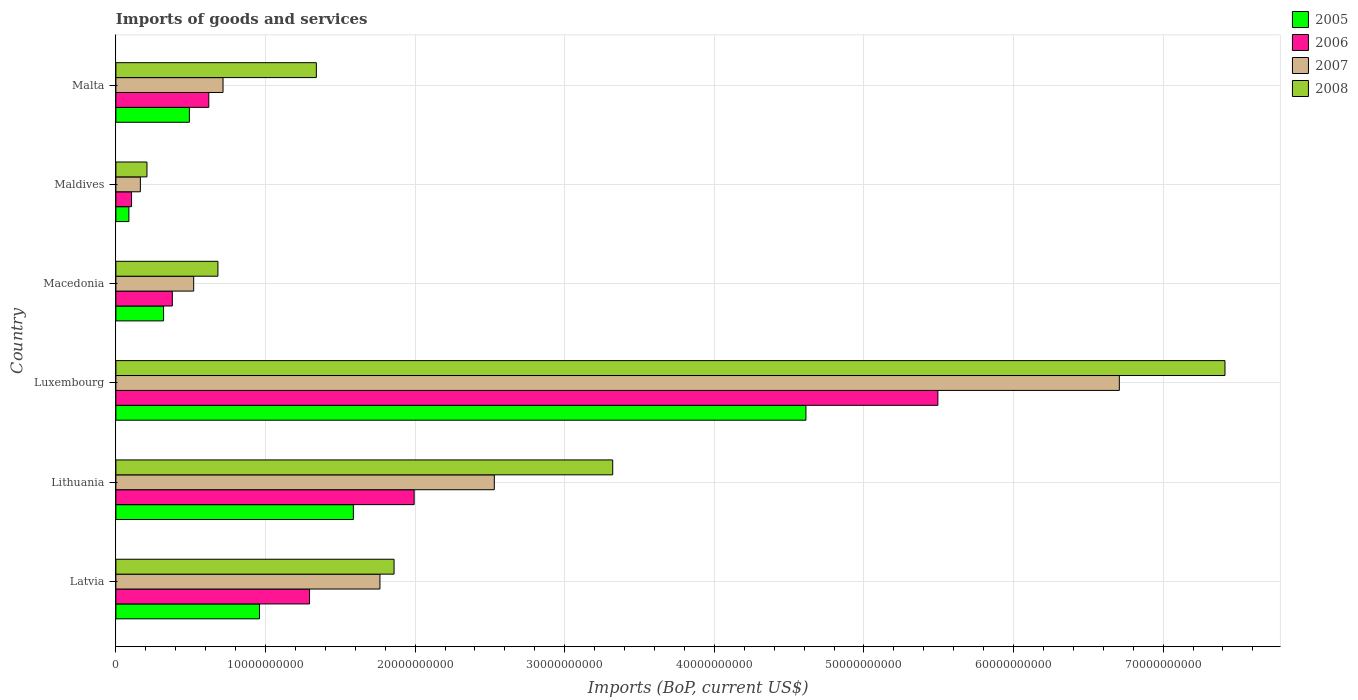How many different coloured bars are there?
Provide a succinct answer. 4. How many groups of bars are there?
Make the answer very short. 6. Are the number of bars per tick equal to the number of legend labels?
Give a very brief answer. Yes. How many bars are there on the 6th tick from the bottom?
Give a very brief answer. 4. What is the label of the 6th group of bars from the top?
Your response must be concise. Latvia. In how many cases, is the number of bars for a given country not equal to the number of legend labels?
Your answer should be very brief. 0. What is the amount spent on imports in 2008 in Lithuania?
Provide a succinct answer. 3.32e+1. Across all countries, what is the maximum amount spent on imports in 2005?
Offer a terse response. 4.61e+1. Across all countries, what is the minimum amount spent on imports in 2007?
Make the answer very short. 1.64e+09. In which country was the amount spent on imports in 2008 maximum?
Provide a succinct answer. Luxembourg. In which country was the amount spent on imports in 2007 minimum?
Offer a very short reply. Maldives. What is the total amount spent on imports in 2007 in the graph?
Provide a short and direct response. 1.24e+11. What is the difference between the amount spent on imports in 2007 in Macedonia and that in Maldives?
Give a very brief answer. 3.56e+09. What is the difference between the amount spent on imports in 2005 in Malta and the amount spent on imports in 2008 in Lithuania?
Provide a short and direct response. -2.83e+1. What is the average amount spent on imports in 2005 per country?
Your response must be concise. 1.34e+1. What is the difference between the amount spent on imports in 2005 and amount spent on imports in 2006 in Macedonia?
Your response must be concise. -5.85e+08. In how many countries, is the amount spent on imports in 2008 greater than 70000000000 US$?
Your response must be concise. 1. What is the ratio of the amount spent on imports in 2006 in Latvia to that in Lithuania?
Provide a short and direct response. 0.65. What is the difference between the highest and the second highest amount spent on imports in 2007?
Provide a succinct answer. 4.18e+1. What is the difference between the highest and the lowest amount spent on imports in 2007?
Offer a terse response. 6.54e+1. In how many countries, is the amount spent on imports in 2008 greater than the average amount spent on imports in 2008 taken over all countries?
Provide a succinct answer. 2. Is the sum of the amount spent on imports in 2005 in Luxembourg and Macedonia greater than the maximum amount spent on imports in 2007 across all countries?
Keep it short and to the point. No. Is it the case that in every country, the sum of the amount spent on imports in 2007 and amount spent on imports in 2008 is greater than the amount spent on imports in 2005?
Your answer should be compact. Yes. Are all the bars in the graph horizontal?
Your answer should be compact. Yes. What is the difference between two consecutive major ticks on the X-axis?
Offer a very short reply. 1.00e+1. Does the graph contain grids?
Offer a terse response. Yes. Where does the legend appear in the graph?
Provide a succinct answer. Top right. How many legend labels are there?
Provide a succinct answer. 4. What is the title of the graph?
Make the answer very short. Imports of goods and services. What is the label or title of the X-axis?
Your answer should be compact. Imports (BoP, current US$). What is the Imports (BoP, current US$) in 2005 in Latvia?
Offer a very short reply. 9.60e+09. What is the Imports (BoP, current US$) of 2006 in Latvia?
Provide a succinct answer. 1.29e+1. What is the Imports (BoP, current US$) in 2007 in Latvia?
Make the answer very short. 1.76e+1. What is the Imports (BoP, current US$) in 2008 in Latvia?
Give a very brief answer. 1.86e+1. What is the Imports (BoP, current US$) of 2005 in Lithuania?
Provide a succinct answer. 1.59e+1. What is the Imports (BoP, current US$) in 2006 in Lithuania?
Your response must be concise. 1.99e+1. What is the Imports (BoP, current US$) in 2007 in Lithuania?
Give a very brief answer. 2.53e+1. What is the Imports (BoP, current US$) in 2008 in Lithuania?
Offer a terse response. 3.32e+1. What is the Imports (BoP, current US$) in 2005 in Luxembourg?
Your response must be concise. 4.61e+1. What is the Imports (BoP, current US$) of 2006 in Luxembourg?
Provide a short and direct response. 5.49e+1. What is the Imports (BoP, current US$) of 2007 in Luxembourg?
Provide a short and direct response. 6.71e+1. What is the Imports (BoP, current US$) in 2008 in Luxembourg?
Offer a terse response. 7.41e+1. What is the Imports (BoP, current US$) in 2005 in Macedonia?
Your answer should be very brief. 3.19e+09. What is the Imports (BoP, current US$) in 2006 in Macedonia?
Make the answer very short. 3.77e+09. What is the Imports (BoP, current US$) in 2007 in Macedonia?
Provide a succinct answer. 5.20e+09. What is the Imports (BoP, current US$) in 2008 in Macedonia?
Your answer should be compact. 6.82e+09. What is the Imports (BoP, current US$) in 2005 in Maldives?
Provide a short and direct response. 8.69e+08. What is the Imports (BoP, current US$) of 2006 in Maldives?
Provide a short and direct response. 1.05e+09. What is the Imports (BoP, current US$) of 2007 in Maldives?
Your response must be concise. 1.64e+09. What is the Imports (BoP, current US$) in 2008 in Maldives?
Your response must be concise. 2.08e+09. What is the Imports (BoP, current US$) in 2005 in Malta?
Provide a short and direct response. 4.91e+09. What is the Imports (BoP, current US$) in 2006 in Malta?
Offer a very short reply. 6.21e+09. What is the Imports (BoP, current US$) in 2007 in Malta?
Make the answer very short. 7.16e+09. What is the Imports (BoP, current US$) of 2008 in Malta?
Keep it short and to the point. 1.34e+1. Across all countries, what is the maximum Imports (BoP, current US$) of 2005?
Keep it short and to the point. 4.61e+1. Across all countries, what is the maximum Imports (BoP, current US$) in 2006?
Give a very brief answer. 5.49e+1. Across all countries, what is the maximum Imports (BoP, current US$) in 2007?
Offer a very short reply. 6.71e+1. Across all countries, what is the maximum Imports (BoP, current US$) in 2008?
Make the answer very short. 7.41e+1. Across all countries, what is the minimum Imports (BoP, current US$) in 2005?
Offer a terse response. 8.69e+08. Across all countries, what is the minimum Imports (BoP, current US$) of 2006?
Offer a terse response. 1.05e+09. Across all countries, what is the minimum Imports (BoP, current US$) of 2007?
Offer a terse response. 1.64e+09. Across all countries, what is the minimum Imports (BoP, current US$) of 2008?
Provide a short and direct response. 2.08e+09. What is the total Imports (BoP, current US$) of 2005 in the graph?
Your answer should be compact. 8.06e+1. What is the total Imports (BoP, current US$) of 2006 in the graph?
Offer a terse response. 9.89e+1. What is the total Imports (BoP, current US$) of 2007 in the graph?
Give a very brief answer. 1.24e+11. What is the total Imports (BoP, current US$) in 2008 in the graph?
Make the answer very short. 1.48e+11. What is the difference between the Imports (BoP, current US$) of 2005 in Latvia and that in Lithuania?
Give a very brief answer. -6.28e+09. What is the difference between the Imports (BoP, current US$) in 2006 in Latvia and that in Lithuania?
Keep it short and to the point. -6.99e+09. What is the difference between the Imports (BoP, current US$) of 2007 in Latvia and that in Lithuania?
Offer a terse response. -7.65e+09. What is the difference between the Imports (BoP, current US$) in 2008 in Latvia and that in Lithuania?
Keep it short and to the point. -1.46e+1. What is the difference between the Imports (BoP, current US$) in 2005 in Latvia and that in Luxembourg?
Offer a very short reply. -3.65e+1. What is the difference between the Imports (BoP, current US$) in 2006 in Latvia and that in Luxembourg?
Provide a succinct answer. -4.20e+1. What is the difference between the Imports (BoP, current US$) of 2007 in Latvia and that in Luxembourg?
Give a very brief answer. -4.94e+1. What is the difference between the Imports (BoP, current US$) of 2008 in Latvia and that in Luxembourg?
Offer a very short reply. -5.55e+1. What is the difference between the Imports (BoP, current US$) in 2005 in Latvia and that in Macedonia?
Your response must be concise. 6.41e+09. What is the difference between the Imports (BoP, current US$) in 2006 in Latvia and that in Macedonia?
Your answer should be compact. 9.17e+09. What is the difference between the Imports (BoP, current US$) of 2007 in Latvia and that in Macedonia?
Ensure brevity in your answer.  1.24e+1. What is the difference between the Imports (BoP, current US$) in 2008 in Latvia and that in Macedonia?
Give a very brief answer. 1.18e+1. What is the difference between the Imports (BoP, current US$) of 2005 in Latvia and that in Maldives?
Your response must be concise. 8.73e+09. What is the difference between the Imports (BoP, current US$) in 2006 in Latvia and that in Maldives?
Keep it short and to the point. 1.19e+1. What is the difference between the Imports (BoP, current US$) in 2007 in Latvia and that in Maldives?
Your answer should be compact. 1.60e+1. What is the difference between the Imports (BoP, current US$) of 2008 in Latvia and that in Maldives?
Your response must be concise. 1.65e+1. What is the difference between the Imports (BoP, current US$) of 2005 in Latvia and that in Malta?
Keep it short and to the point. 4.69e+09. What is the difference between the Imports (BoP, current US$) of 2006 in Latvia and that in Malta?
Your answer should be compact. 6.73e+09. What is the difference between the Imports (BoP, current US$) of 2007 in Latvia and that in Malta?
Keep it short and to the point. 1.05e+1. What is the difference between the Imports (BoP, current US$) of 2008 in Latvia and that in Malta?
Offer a terse response. 5.20e+09. What is the difference between the Imports (BoP, current US$) of 2005 in Lithuania and that in Luxembourg?
Give a very brief answer. -3.03e+1. What is the difference between the Imports (BoP, current US$) in 2006 in Lithuania and that in Luxembourg?
Provide a succinct answer. -3.50e+1. What is the difference between the Imports (BoP, current US$) in 2007 in Lithuania and that in Luxembourg?
Your answer should be very brief. -4.18e+1. What is the difference between the Imports (BoP, current US$) of 2008 in Lithuania and that in Luxembourg?
Offer a terse response. -4.09e+1. What is the difference between the Imports (BoP, current US$) in 2005 in Lithuania and that in Macedonia?
Your answer should be very brief. 1.27e+1. What is the difference between the Imports (BoP, current US$) of 2006 in Lithuania and that in Macedonia?
Offer a terse response. 1.62e+1. What is the difference between the Imports (BoP, current US$) in 2007 in Lithuania and that in Macedonia?
Provide a short and direct response. 2.01e+1. What is the difference between the Imports (BoP, current US$) of 2008 in Lithuania and that in Macedonia?
Provide a succinct answer. 2.64e+1. What is the difference between the Imports (BoP, current US$) in 2005 in Lithuania and that in Maldives?
Ensure brevity in your answer.  1.50e+1. What is the difference between the Imports (BoP, current US$) in 2006 in Lithuania and that in Maldives?
Keep it short and to the point. 1.89e+1. What is the difference between the Imports (BoP, current US$) in 2007 in Lithuania and that in Maldives?
Make the answer very short. 2.37e+1. What is the difference between the Imports (BoP, current US$) in 2008 in Lithuania and that in Maldives?
Your answer should be compact. 3.11e+1. What is the difference between the Imports (BoP, current US$) in 2005 in Lithuania and that in Malta?
Give a very brief answer. 1.10e+1. What is the difference between the Imports (BoP, current US$) in 2006 in Lithuania and that in Malta?
Give a very brief answer. 1.37e+1. What is the difference between the Imports (BoP, current US$) in 2007 in Lithuania and that in Malta?
Your answer should be compact. 1.81e+1. What is the difference between the Imports (BoP, current US$) of 2008 in Lithuania and that in Malta?
Offer a terse response. 1.98e+1. What is the difference between the Imports (BoP, current US$) of 2005 in Luxembourg and that in Macedonia?
Your response must be concise. 4.29e+1. What is the difference between the Imports (BoP, current US$) in 2006 in Luxembourg and that in Macedonia?
Keep it short and to the point. 5.12e+1. What is the difference between the Imports (BoP, current US$) in 2007 in Luxembourg and that in Macedonia?
Your response must be concise. 6.19e+1. What is the difference between the Imports (BoP, current US$) of 2008 in Luxembourg and that in Macedonia?
Give a very brief answer. 6.73e+1. What is the difference between the Imports (BoP, current US$) in 2005 in Luxembourg and that in Maldives?
Ensure brevity in your answer.  4.53e+1. What is the difference between the Imports (BoP, current US$) in 2006 in Luxembourg and that in Maldives?
Provide a succinct answer. 5.39e+1. What is the difference between the Imports (BoP, current US$) in 2007 in Luxembourg and that in Maldives?
Give a very brief answer. 6.54e+1. What is the difference between the Imports (BoP, current US$) of 2008 in Luxembourg and that in Maldives?
Offer a very short reply. 7.21e+1. What is the difference between the Imports (BoP, current US$) in 2005 in Luxembourg and that in Malta?
Give a very brief answer. 4.12e+1. What is the difference between the Imports (BoP, current US$) of 2006 in Luxembourg and that in Malta?
Provide a short and direct response. 4.87e+1. What is the difference between the Imports (BoP, current US$) of 2007 in Luxembourg and that in Malta?
Ensure brevity in your answer.  5.99e+1. What is the difference between the Imports (BoP, current US$) of 2008 in Luxembourg and that in Malta?
Your response must be concise. 6.07e+1. What is the difference between the Imports (BoP, current US$) of 2005 in Macedonia and that in Maldives?
Offer a very short reply. 2.32e+09. What is the difference between the Imports (BoP, current US$) of 2006 in Macedonia and that in Maldives?
Your response must be concise. 2.73e+09. What is the difference between the Imports (BoP, current US$) of 2007 in Macedonia and that in Maldives?
Offer a very short reply. 3.56e+09. What is the difference between the Imports (BoP, current US$) in 2008 in Macedonia and that in Maldives?
Your answer should be compact. 4.74e+09. What is the difference between the Imports (BoP, current US$) of 2005 in Macedonia and that in Malta?
Give a very brief answer. -1.72e+09. What is the difference between the Imports (BoP, current US$) of 2006 in Macedonia and that in Malta?
Provide a succinct answer. -2.44e+09. What is the difference between the Imports (BoP, current US$) of 2007 in Macedonia and that in Malta?
Provide a short and direct response. -1.96e+09. What is the difference between the Imports (BoP, current US$) of 2008 in Macedonia and that in Malta?
Ensure brevity in your answer.  -6.58e+09. What is the difference between the Imports (BoP, current US$) of 2005 in Maldives and that in Malta?
Your answer should be very brief. -4.04e+09. What is the difference between the Imports (BoP, current US$) in 2006 in Maldives and that in Malta?
Keep it short and to the point. -5.16e+09. What is the difference between the Imports (BoP, current US$) in 2007 in Maldives and that in Malta?
Provide a short and direct response. -5.53e+09. What is the difference between the Imports (BoP, current US$) in 2008 in Maldives and that in Malta?
Offer a very short reply. -1.13e+1. What is the difference between the Imports (BoP, current US$) of 2005 in Latvia and the Imports (BoP, current US$) of 2006 in Lithuania?
Offer a terse response. -1.03e+1. What is the difference between the Imports (BoP, current US$) of 2005 in Latvia and the Imports (BoP, current US$) of 2007 in Lithuania?
Give a very brief answer. -1.57e+1. What is the difference between the Imports (BoP, current US$) in 2005 in Latvia and the Imports (BoP, current US$) in 2008 in Lithuania?
Keep it short and to the point. -2.36e+1. What is the difference between the Imports (BoP, current US$) in 2006 in Latvia and the Imports (BoP, current US$) in 2007 in Lithuania?
Your answer should be very brief. -1.24e+1. What is the difference between the Imports (BoP, current US$) in 2006 in Latvia and the Imports (BoP, current US$) in 2008 in Lithuania?
Your answer should be very brief. -2.03e+1. What is the difference between the Imports (BoP, current US$) in 2007 in Latvia and the Imports (BoP, current US$) in 2008 in Lithuania?
Offer a terse response. -1.56e+1. What is the difference between the Imports (BoP, current US$) of 2005 in Latvia and the Imports (BoP, current US$) of 2006 in Luxembourg?
Your answer should be compact. -4.53e+1. What is the difference between the Imports (BoP, current US$) of 2005 in Latvia and the Imports (BoP, current US$) of 2007 in Luxembourg?
Provide a succinct answer. -5.75e+1. What is the difference between the Imports (BoP, current US$) of 2005 in Latvia and the Imports (BoP, current US$) of 2008 in Luxembourg?
Provide a short and direct response. -6.45e+1. What is the difference between the Imports (BoP, current US$) of 2006 in Latvia and the Imports (BoP, current US$) of 2007 in Luxembourg?
Offer a terse response. -5.41e+1. What is the difference between the Imports (BoP, current US$) in 2006 in Latvia and the Imports (BoP, current US$) in 2008 in Luxembourg?
Your answer should be very brief. -6.12e+1. What is the difference between the Imports (BoP, current US$) of 2007 in Latvia and the Imports (BoP, current US$) of 2008 in Luxembourg?
Keep it short and to the point. -5.65e+1. What is the difference between the Imports (BoP, current US$) of 2005 in Latvia and the Imports (BoP, current US$) of 2006 in Macedonia?
Provide a short and direct response. 5.83e+09. What is the difference between the Imports (BoP, current US$) of 2005 in Latvia and the Imports (BoP, current US$) of 2007 in Macedonia?
Keep it short and to the point. 4.40e+09. What is the difference between the Imports (BoP, current US$) of 2005 in Latvia and the Imports (BoP, current US$) of 2008 in Macedonia?
Ensure brevity in your answer.  2.78e+09. What is the difference between the Imports (BoP, current US$) in 2006 in Latvia and the Imports (BoP, current US$) in 2007 in Macedonia?
Provide a succinct answer. 7.74e+09. What is the difference between the Imports (BoP, current US$) of 2006 in Latvia and the Imports (BoP, current US$) of 2008 in Macedonia?
Your answer should be compact. 6.12e+09. What is the difference between the Imports (BoP, current US$) in 2007 in Latvia and the Imports (BoP, current US$) in 2008 in Macedonia?
Give a very brief answer. 1.08e+1. What is the difference between the Imports (BoP, current US$) in 2005 in Latvia and the Imports (BoP, current US$) in 2006 in Maldives?
Your answer should be compact. 8.55e+09. What is the difference between the Imports (BoP, current US$) of 2005 in Latvia and the Imports (BoP, current US$) of 2007 in Maldives?
Provide a short and direct response. 7.96e+09. What is the difference between the Imports (BoP, current US$) in 2005 in Latvia and the Imports (BoP, current US$) in 2008 in Maldives?
Your response must be concise. 7.52e+09. What is the difference between the Imports (BoP, current US$) in 2006 in Latvia and the Imports (BoP, current US$) in 2007 in Maldives?
Offer a very short reply. 1.13e+1. What is the difference between the Imports (BoP, current US$) of 2006 in Latvia and the Imports (BoP, current US$) of 2008 in Maldives?
Ensure brevity in your answer.  1.09e+1. What is the difference between the Imports (BoP, current US$) in 2007 in Latvia and the Imports (BoP, current US$) in 2008 in Maldives?
Ensure brevity in your answer.  1.56e+1. What is the difference between the Imports (BoP, current US$) of 2005 in Latvia and the Imports (BoP, current US$) of 2006 in Malta?
Your response must be concise. 3.39e+09. What is the difference between the Imports (BoP, current US$) of 2005 in Latvia and the Imports (BoP, current US$) of 2007 in Malta?
Offer a very short reply. 2.44e+09. What is the difference between the Imports (BoP, current US$) of 2005 in Latvia and the Imports (BoP, current US$) of 2008 in Malta?
Offer a very short reply. -3.80e+09. What is the difference between the Imports (BoP, current US$) of 2006 in Latvia and the Imports (BoP, current US$) of 2007 in Malta?
Your answer should be very brief. 5.78e+09. What is the difference between the Imports (BoP, current US$) of 2006 in Latvia and the Imports (BoP, current US$) of 2008 in Malta?
Provide a succinct answer. -4.55e+08. What is the difference between the Imports (BoP, current US$) of 2007 in Latvia and the Imports (BoP, current US$) of 2008 in Malta?
Offer a very short reply. 4.25e+09. What is the difference between the Imports (BoP, current US$) of 2005 in Lithuania and the Imports (BoP, current US$) of 2006 in Luxembourg?
Your response must be concise. -3.91e+1. What is the difference between the Imports (BoP, current US$) in 2005 in Lithuania and the Imports (BoP, current US$) in 2007 in Luxembourg?
Provide a short and direct response. -5.12e+1. What is the difference between the Imports (BoP, current US$) of 2005 in Lithuania and the Imports (BoP, current US$) of 2008 in Luxembourg?
Offer a terse response. -5.83e+1. What is the difference between the Imports (BoP, current US$) in 2006 in Lithuania and the Imports (BoP, current US$) in 2007 in Luxembourg?
Provide a succinct answer. -4.71e+1. What is the difference between the Imports (BoP, current US$) in 2006 in Lithuania and the Imports (BoP, current US$) in 2008 in Luxembourg?
Give a very brief answer. -5.42e+1. What is the difference between the Imports (BoP, current US$) of 2007 in Lithuania and the Imports (BoP, current US$) of 2008 in Luxembourg?
Keep it short and to the point. -4.88e+1. What is the difference between the Imports (BoP, current US$) of 2005 in Lithuania and the Imports (BoP, current US$) of 2006 in Macedonia?
Your answer should be compact. 1.21e+1. What is the difference between the Imports (BoP, current US$) in 2005 in Lithuania and the Imports (BoP, current US$) in 2007 in Macedonia?
Make the answer very short. 1.07e+1. What is the difference between the Imports (BoP, current US$) in 2005 in Lithuania and the Imports (BoP, current US$) in 2008 in Macedonia?
Give a very brief answer. 9.05e+09. What is the difference between the Imports (BoP, current US$) of 2006 in Lithuania and the Imports (BoP, current US$) of 2007 in Macedonia?
Offer a very short reply. 1.47e+1. What is the difference between the Imports (BoP, current US$) in 2006 in Lithuania and the Imports (BoP, current US$) in 2008 in Macedonia?
Ensure brevity in your answer.  1.31e+1. What is the difference between the Imports (BoP, current US$) of 2007 in Lithuania and the Imports (BoP, current US$) of 2008 in Macedonia?
Provide a short and direct response. 1.85e+1. What is the difference between the Imports (BoP, current US$) in 2005 in Lithuania and the Imports (BoP, current US$) in 2006 in Maldives?
Your answer should be compact. 1.48e+1. What is the difference between the Imports (BoP, current US$) of 2005 in Lithuania and the Imports (BoP, current US$) of 2007 in Maldives?
Ensure brevity in your answer.  1.42e+1. What is the difference between the Imports (BoP, current US$) in 2005 in Lithuania and the Imports (BoP, current US$) in 2008 in Maldives?
Make the answer very short. 1.38e+1. What is the difference between the Imports (BoP, current US$) in 2006 in Lithuania and the Imports (BoP, current US$) in 2007 in Maldives?
Make the answer very short. 1.83e+1. What is the difference between the Imports (BoP, current US$) of 2006 in Lithuania and the Imports (BoP, current US$) of 2008 in Maldives?
Ensure brevity in your answer.  1.79e+1. What is the difference between the Imports (BoP, current US$) of 2007 in Lithuania and the Imports (BoP, current US$) of 2008 in Maldives?
Give a very brief answer. 2.32e+1. What is the difference between the Imports (BoP, current US$) in 2005 in Lithuania and the Imports (BoP, current US$) in 2006 in Malta?
Ensure brevity in your answer.  9.66e+09. What is the difference between the Imports (BoP, current US$) in 2005 in Lithuania and the Imports (BoP, current US$) in 2007 in Malta?
Your response must be concise. 8.71e+09. What is the difference between the Imports (BoP, current US$) in 2005 in Lithuania and the Imports (BoP, current US$) in 2008 in Malta?
Give a very brief answer. 2.47e+09. What is the difference between the Imports (BoP, current US$) in 2006 in Lithuania and the Imports (BoP, current US$) in 2007 in Malta?
Your answer should be very brief. 1.28e+1. What is the difference between the Imports (BoP, current US$) of 2006 in Lithuania and the Imports (BoP, current US$) of 2008 in Malta?
Give a very brief answer. 6.54e+09. What is the difference between the Imports (BoP, current US$) in 2007 in Lithuania and the Imports (BoP, current US$) in 2008 in Malta?
Offer a very short reply. 1.19e+1. What is the difference between the Imports (BoP, current US$) in 2005 in Luxembourg and the Imports (BoP, current US$) in 2006 in Macedonia?
Offer a terse response. 4.24e+1. What is the difference between the Imports (BoP, current US$) in 2005 in Luxembourg and the Imports (BoP, current US$) in 2007 in Macedonia?
Keep it short and to the point. 4.09e+1. What is the difference between the Imports (BoP, current US$) in 2005 in Luxembourg and the Imports (BoP, current US$) in 2008 in Macedonia?
Your answer should be very brief. 3.93e+1. What is the difference between the Imports (BoP, current US$) of 2006 in Luxembourg and the Imports (BoP, current US$) of 2007 in Macedonia?
Provide a short and direct response. 4.97e+1. What is the difference between the Imports (BoP, current US$) in 2006 in Luxembourg and the Imports (BoP, current US$) in 2008 in Macedonia?
Offer a very short reply. 4.81e+1. What is the difference between the Imports (BoP, current US$) of 2007 in Luxembourg and the Imports (BoP, current US$) of 2008 in Macedonia?
Offer a terse response. 6.03e+1. What is the difference between the Imports (BoP, current US$) in 2005 in Luxembourg and the Imports (BoP, current US$) in 2006 in Maldives?
Your response must be concise. 4.51e+1. What is the difference between the Imports (BoP, current US$) in 2005 in Luxembourg and the Imports (BoP, current US$) in 2007 in Maldives?
Your answer should be compact. 4.45e+1. What is the difference between the Imports (BoP, current US$) in 2005 in Luxembourg and the Imports (BoP, current US$) in 2008 in Maldives?
Offer a very short reply. 4.40e+1. What is the difference between the Imports (BoP, current US$) in 2006 in Luxembourg and the Imports (BoP, current US$) in 2007 in Maldives?
Keep it short and to the point. 5.33e+1. What is the difference between the Imports (BoP, current US$) in 2006 in Luxembourg and the Imports (BoP, current US$) in 2008 in Maldives?
Keep it short and to the point. 5.29e+1. What is the difference between the Imports (BoP, current US$) of 2007 in Luxembourg and the Imports (BoP, current US$) of 2008 in Maldives?
Your response must be concise. 6.50e+1. What is the difference between the Imports (BoP, current US$) in 2005 in Luxembourg and the Imports (BoP, current US$) in 2006 in Malta?
Make the answer very short. 3.99e+1. What is the difference between the Imports (BoP, current US$) in 2005 in Luxembourg and the Imports (BoP, current US$) in 2007 in Malta?
Your answer should be very brief. 3.90e+1. What is the difference between the Imports (BoP, current US$) in 2005 in Luxembourg and the Imports (BoP, current US$) in 2008 in Malta?
Give a very brief answer. 3.27e+1. What is the difference between the Imports (BoP, current US$) in 2006 in Luxembourg and the Imports (BoP, current US$) in 2007 in Malta?
Provide a short and direct response. 4.78e+1. What is the difference between the Imports (BoP, current US$) in 2006 in Luxembourg and the Imports (BoP, current US$) in 2008 in Malta?
Provide a short and direct response. 4.15e+1. What is the difference between the Imports (BoP, current US$) of 2007 in Luxembourg and the Imports (BoP, current US$) of 2008 in Malta?
Provide a succinct answer. 5.37e+1. What is the difference between the Imports (BoP, current US$) of 2005 in Macedonia and the Imports (BoP, current US$) of 2006 in Maldives?
Give a very brief answer. 2.14e+09. What is the difference between the Imports (BoP, current US$) of 2005 in Macedonia and the Imports (BoP, current US$) of 2007 in Maldives?
Give a very brief answer. 1.55e+09. What is the difference between the Imports (BoP, current US$) of 2005 in Macedonia and the Imports (BoP, current US$) of 2008 in Maldives?
Offer a very short reply. 1.11e+09. What is the difference between the Imports (BoP, current US$) of 2006 in Macedonia and the Imports (BoP, current US$) of 2007 in Maldives?
Your answer should be very brief. 2.14e+09. What is the difference between the Imports (BoP, current US$) of 2006 in Macedonia and the Imports (BoP, current US$) of 2008 in Maldives?
Your answer should be compact. 1.70e+09. What is the difference between the Imports (BoP, current US$) of 2007 in Macedonia and the Imports (BoP, current US$) of 2008 in Maldives?
Your answer should be very brief. 3.12e+09. What is the difference between the Imports (BoP, current US$) in 2005 in Macedonia and the Imports (BoP, current US$) in 2006 in Malta?
Provide a short and direct response. -3.02e+09. What is the difference between the Imports (BoP, current US$) in 2005 in Macedonia and the Imports (BoP, current US$) in 2007 in Malta?
Your answer should be compact. -3.97e+09. What is the difference between the Imports (BoP, current US$) in 2005 in Macedonia and the Imports (BoP, current US$) in 2008 in Malta?
Make the answer very short. -1.02e+1. What is the difference between the Imports (BoP, current US$) in 2006 in Macedonia and the Imports (BoP, current US$) in 2007 in Malta?
Ensure brevity in your answer.  -3.39e+09. What is the difference between the Imports (BoP, current US$) in 2006 in Macedonia and the Imports (BoP, current US$) in 2008 in Malta?
Provide a succinct answer. -9.63e+09. What is the difference between the Imports (BoP, current US$) of 2007 in Macedonia and the Imports (BoP, current US$) of 2008 in Malta?
Ensure brevity in your answer.  -8.20e+09. What is the difference between the Imports (BoP, current US$) in 2005 in Maldives and the Imports (BoP, current US$) in 2006 in Malta?
Your answer should be very brief. -5.34e+09. What is the difference between the Imports (BoP, current US$) of 2005 in Maldives and the Imports (BoP, current US$) of 2007 in Malta?
Offer a very short reply. -6.29e+09. What is the difference between the Imports (BoP, current US$) of 2005 in Maldives and the Imports (BoP, current US$) of 2008 in Malta?
Ensure brevity in your answer.  -1.25e+1. What is the difference between the Imports (BoP, current US$) in 2006 in Maldives and the Imports (BoP, current US$) in 2007 in Malta?
Offer a very short reply. -6.12e+09. What is the difference between the Imports (BoP, current US$) in 2006 in Maldives and the Imports (BoP, current US$) in 2008 in Malta?
Make the answer very short. -1.24e+1. What is the difference between the Imports (BoP, current US$) in 2007 in Maldives and the Imports (BoP, current US$) in 2008 in Malta?
Provide a short and direct response. -1.18e+1. What is the average Imports (BoP, current US$) of 2005 per country?
Ensure brevity in your answer.  1.34e+1. What is the average Imports (BoP, current US$) in 2006 per country?
Offer a terse response. 1.65e+1. What is the average Imports (BoP, current US$) in 2007 per country?
Provide a short and direct response. 2.07e+1. What is the average Imports (BoP, current US$) of 2008 per country?
Make the answer very short. 2.47e+1. What is the difference between the Imports (BoP, current US$) of 2005 and Imports (BoP, current US$) of 2006 in Latvia?
Give a very brief answer. -3.35e+09. What is the difference between the Imports (BoP, current US$) of 2005 and Imports (BoP, current US$) of 2007 in Latvia?
Keep it short and to the point. -8.05e+09. What is the difference between the Imports (BoP, current US$) in 2005 and Imports (BoP, current US$) in 2008 in Latvia?
Provide a succinct answer. -9.00e+09. What is the difference between the Imports (BoP, current US$) in 2006 and Imports (BoP, current US$) in 2007 in Latvia?
Your answer should be compact. -4.71e+09. What is the difference between the Imports (BoP, current US$) in 2006 and Imports (BoP, current US$) in 2008 in Latvia?
Your response must be concise. -5.65e+09. What is the difference between the Imports (BoP, current US$) of 2007 and Imports (BoP, current US$) of 2008 in Latvia?
Keep it short and to the point. -9.45e+08. What is the difference between the Imports (BoP, current US$) in 2005 and Imports (BoP, current US$) in 2006 in Lithuania?
Offer a very short reply. -4.06e+09. What is the difference between the Imports (BoP, current US$) of 2005 and Imports (BoP, current US$) of 2007 in Lithuania?
Offer a very short reply. -9.42e+09. What is the difference between the Imports (BoP, current US$) in 2005 and Imports (BoP, current US$) in 2008 in Lithuania?
Keep it short and to the point. -1.73e+1. What is the difference between the Imports (BoP, current US$) in 2006 and Imports (BoP, current US$) in 2007 in Lithuania?
Your response must be concise. -5.36e+09. What is the difference between the Imports (BoP, current US$) of 2006 and Imports (BoP, current US$) of 2008 in Lithuania?
Your answer should be compact. -1.33e+1. What is the difference between the Imports (BoP, current US$) of 2007 and Imports (BoP, current US$) of 2008 in Lithuania?
Provide a succinct answer. -7.91e+09. What is the difference between the Imports (BoP, current US$) in 2005 and Imports (BoP, current US$) in 2006 in Luxembourg?
Keep it short and to the point. -8.82e+09. What is the difference between the Imports (BoP, current US$) in 2005 and Imports (BoP, current US$) in 2007 in Luxembourg?
Keep it short and to the point. -2.09e+1. What is the difference between the Imports (BoP, current US$) of 2005 and Imports (BoP, current US$) of 2008 in Luxembourg?
Provide a short and direct response. -2.80e+1. What is the difference between the Imports (BoP, current US$) in 2006 and Imports (BoP, current US$) in 2007 in Luxembourg?
Offer a terse response. -1.21e+1. What is the difference between the Imports (BoP, current US$) of 2006 and Imports (BoP, current US$) of 2008 in Luxembourg?
Provide a succinct answer. -1.92e+1. What is the difference between the Imports (BoP, current US$) in 2007 and Imports (BoP, current US$) in 2008 in Luxembourg?
Ensure brevity in your answer.  -7.06e+09. What is the difference between the Imports (BoP, current US$) of 2005 and Imports (BoP, current US$) of 2006 in Macedonia?
Keep it short and to the point. -5.85e+08. What is the difference between the Imports (BoP, current US$) in 2005 and Imports (BoP, current US$) in 2007 in Macedonia?
Your answer should be very brief. -2.01e+09. What is the difference between the Imports (BoP, current US$) in 2005 and Imports (BoP, current US$) in 2008 in Macedonia?
Offer a terse response. -3.63e+09. What is the difference between the Imports (BoP, current US$) in 2006 and Imports (BoP, current US$) in 2007 in Macedonia?
Ensure brevity in your answer.  -1.43e+09. What is the difference between the Imports (BoP, current US$) in 2006 and Imports (BoP, current US$) in 2008 in Macedonia?
Provide a succinct answer. -3.05e+09. What is the difference between the Imports (BoP, current US$) of 2007 and Imports (BoP, current US$) of 2008 in Macedonia?
Your response must be concise. -1.62e+09. What is the difference between the Imports (BoP, current US$) in 2005 and Imports (BoP, current US$) in 2006 in Maldives?
Keep it short and to the point. -1.78e+08. What is the difference between the Imports (BoP, current US$) in 2005 and Imports (BoP, current US$) in 2007 in Maldives?
Keep it short and to the point. -7.67e+08. What is the difference between the Imports (BoP, current US$) of 2005 and Imports (BoP, current US$) of 2008 in Maldives?
Your answer should be very brief. -1.21e+09. What is the difference between the Imports (BoP, current US$) of 2006 and Imports (BoP, current US$) of 2007 in Maldives?
Provide a short and direct response. -5.89e+08. What is the difference between the Imports (BoP, current US$) in 2006 and Imports (BoP, current US$) in 2008 in Maldives?
Give a very brief answer. -1.03e+09. What is the difference between the Imports (BoP, current US$) in 2007 and Imports (BoP, current US$) in 2008 in Maldives?
Provide a short and direct response. -4.41e+08. What is the difference between the Imports (BoP, current US$) of 2005 and Imports (BoP, current US$) of 2006 in Malta?
Make the answer very short. -1.30e+09. What is the difference between the Imports (BoP, current US$) of 2005 and Imports (BoP, current US$) of 2007 in Malta?
Ensure brevity in your answer.  -2.25e+09. What is the difference between the Imports (BoP, current US$) of 2005 and Imports (BoP, current US$) of 2008 in Malta?
Give a very brief answer. -8.49e+09. What is the difference between the Imports (BoP, current US$) in 2006 and Imports (BoP, current US$) in 2007 in Malta?
Give a very brief answer. -9.52e+08. What is the difference between the Imports (BoP, current US$) of 2006 and Imports (BoP, current US$) of 2008 in Malta?
Give a very brief answer. -7.19e+09. What is the difference between the Imports (BoP, current US$) of 2007 and Imports (BoP, current US$) of 2008 in Malta?
Offer a very short reply. -6.24e+09. What is the ratio of the Imports (BoP, current US$) in 2005 in Latvia to that in Lithuania?
Offer a terse response. 0.6. What is the ratio of the Imports (BoP, current US$) of 2006 in Latvia to that in Lithuania?
Offer a terse response. 0.65. What is the ratio of the Imports (BoP, current US$) in 2007 in Latvia to that in Lithuania?
Give a very brief answer. 0.7. What is the ratio of the Imports (BoP, current US$) of 2008 in Latvia to that in Lithuania?
Ensure brevity in your answer.  0.56. What is the ratio of the Imports (BoP, current US$) in 2005 in Latvia to that in Luxembourg?
Your answer should be very brief. 0.21. What is the ratio of the Imports (BoP, current US$) in 2006 in Latvia to that in Luxembourg?
Your response must be concise. 0.24. What is the ratio of the Imports (BoP, current US$) of 2007 in Latvia to that in Luxembourg?
Your answer should be compact. 0.26. What is the ratio of the Imports (BoP, current US$) of 2008 in Latvia to that in Luxembourg?
Your answer should be very brief. 0.25. What is the ratio of the Imports (BoP, current US$) in 2005 in Latvia to that in Macedonia?
Keep it short and to the point. 3.01. What is the ratio of the Imports (BoP, current US$) in 2006 in Latvia to that in Macedonia?
Your answer should be very brief. 3.43. What is the ratio of the Imports (BoP, current US$) in 2007 in Latvia to that in Macedonia?
Give a very brief answer. 3.39. What is the ratio of the Imports (BoP, current US$) of 2008 in Latvia to that in Macedonia?
Your response must be concise. 2.73. What is the ratio of the Imports (BoP, current US$) of 2005 in Latvia to that in Maldives?
Provide a succinct answer. 11.05. What is the ratio of the Imports (BoP, current US$) of 2006 in Latvia to that in Maldives?
Give a very brief answer. 12.37. What is the ratio of the Imports (BoP, current US$) in 2007 in Latvia to that in Maldives?
Ensure brevity in your answer.  10.79. What is the ratio of the Imports (BoP, current US$) in 2008 in Latvia to that in Maldives?
Give a very brief answer. 8.95. What is the ratio of the Imports (BoP, current US$) in 2005 in Latvia to that in Malta?
Provide a short and direct response. 1.95. What is the ratio of the Imports (BoP, current US$) of 2006 in Latvia to that in Malta?
Your response must be concise. 2.08. What is the ratio of the Imports (BoP, current US$) of 2007 in Latvia to that in Malta?
Make the answer very short. 2.46. What is the ratio of the Imports (BoP, current US$) in 2008 in Latvia to that in Malta?
Your response must be concise. 1.39. What is the ratio of the Imports (BoP, current US$) of 2005 in Lithuania to that in Luxembourg?
Your answer should be very brief. 0.34. What is the ratio of the Imports (BoP, current US$) of 2006 in Lithuania to that in Luxembourg?
Give a very brief answer. 0.36. What is the ratio of the Imports (BoP, current US$) in 2007 in Lithuania to that in Luxembourg?
Keep it short and to the point. 0.38. What is the ratio of the Imports (BoP, current US$) in 2008 in Lithuania to that in Luxembourg?
Provide a succinct answer. 0.45. What is the ratio of the Imports (BoP, current US$) in 2005 in Lithuania to that in Macedonia?
Give a very brief answer. 4.98. What is the ratio of the Imports (BoP, current US$) in 2006 in Lithuania to that in Macedonia?
Your response must be concise. 5.28. What is the ratio of the Imports (BoP, current US$) of 2007 in Lithuania to that in Macedonia?
Keep it short and to the point. 4.86. What is the ratio of the Imports (BoP, current US$) of 2008 in Lithuania to that in Macedonia?
Your answer should be very brief. 4.87. What is the ratio of the Imports (BoP, current US$) of 2005 in Lithuania to that in Maldives?
Your answer should be very brief. 18.28. What is the ratio of the Imports (BoP, current US$) in 2006 in Lithuania to that in Maldives?
Your answer should be compact. 19.05. What is the ratio of the Imports (BoP, current US$) of 2007 in Lithuania to that in Maldives?
Keep it short and to the point. 15.46. What is the ratio of the Imports (BoP, current US$) in 2008 in Lithuania to that in Maldives?
Offer a terse response. 15.99. What is the ratio of the Imports (BoP, current US$) in 2005 in Lithuania to that in Malta?
Make the answer very short. 3.23. What is the ratio of the Imports (BoP, current US$) in 2006 in Lithuania to that in Malta?
Offer a very short reply. 3.21. What is the ratio of the Imports (BoP, current US$) in 2007 in Lithuania to that in Malta?
Your answer should be compact. 3.53. What is the ratio of the Imports (BoP, current US$) in 2008 in Lithuania to that in Malta?
Your response must be concise. 2.48. What is the ratio of the Imports (BoP, current US$) in 2005 in Luxembourg to that in Macedonia?
Keep it short and to the point. 14.47. What is the ratio of the Imports (BoP, current US$) in 2006 in Luxembourg to that in Macedonia?
Ensure brevity in your answer.  14.56. What is the ratio of the Imports (BoP, current US$) of 2007 in Luxembourg to that in Macedonia?
Provide a succinct answer. 12.9. What is the ratio of the Imports (BoP, current US$) of 2008 in Luxembourg to that in Macedonia?
Offer a very short reply. 10.87. What is the ratio of the Imports (BoP, current US$) of 2005 in Luxembourg to that in Maldives?
Your answer should be very brief. 53.1. What is the ratio of the Imports (BoP, current US$) of 2006 in Luxembourg to that in Maldives?
Give a very brief answer. 52.5. What is the ratio of the Imports (BoP, current US$) of 2007 in Luxembourg to that in Maldives?
Provide a short and direct response. 41.01. What is the ratio of the Imports (BoP, current US$) of 2008 in Luxembourg to that in Maldives?
Your answer should be compact. 35.69. What is the ratio of the Imports (BoP, current US$) of 2005 in Luxembourg to that in Malta?
Your answer should be compact. 9.39. What is the ratio of the Imports (BoP, current US$) in 2006 in Luxembourg to that in Malta?
Your response must be concise. 8.85. What is the ratio of the Imports (BoP, current US$) of 2007 in Luxembourg to that in Malta?
Give a very brief answer. 9.36. What is the ratio of the Imports (BoP, current US$) of 2008 in Luxembourg to that in Malta?
Your answer should be compact. 5.53. What is the ratio of the Imports (BoP, current US$) of 2005 in Macedonia to that in Maldives?
Your response must be concise. 3.67. What is the ratio of the Imports (BoP, current US$) in 2006 in Macedonia to that in Maldives?
Your response must be concise. 3.6. What is the ratio of the Imports (BoP, current US$) of 2007 in Macedonia to that in Maldives?
Make the answer very short. 3.18. What is the ratio of the Imports (BoP, current US$) of 2008 in Macedonia to that in Maldives?
Provide a short and direct response. 3.28. What is the ratio of the Imports (BoP, current US$) of 2005 in Macedonia to that in Malta?
Keep it short and to the point. 0.65. What is the ratio of the Imports (BoP, current US$) in 2006 in Macedonia to that in Malta?
Ensure brevity in your answer.  0.61. What is the ratio of the Imports (BoP, current US$) of 2007 in Macedonia to that in Malta?
Keep it short and to the point. 0.73. What is the ratio of the Imports (BoP, current US$) in 2008 in Macedonia to that in Malta?
Your response must be concise. 0.51. What is the ratio of the Imports (BoP, current US$) in 2005 in Maldives to that in Malta?
Keep it short and to the point. 0.18. What is the ratio of the Imports (BoP, current US$) in 2006 in Maldives to that in Malta?
Offer a very short reply. 0.17. What is the ratio of the Imports (BoP, current US$) in 2007 in Maldives to that in Malta?
Offer a terse response. 0.23. What is the ratio of the Imports (BoP, current US$) of 2008 in Maldives to that in Malta?
Provide a short and direct response. 0.15. What is the difference between the highest and the second highest Imports (BoP, current US$) of 2005?
Your response must be concise. 3.03e+1. What is the difference between the highest and the second highest Imports (BoP, current US$) of 2006?
Your answer should be compact. 3.50e+1. What is the difference between the highest and the second highest Imports (BoP, current US$) of 2007?
Keep it short and to the point. 4.18e+1. What is the difference between the highest and the second highest Imports (BoP, current US$) of 2008?
Keep it short and to the point. 4.09e+1. What is the difference between the highest and the lowest Imports (BoP, current US$) in 2005?
Offer a terse response. 4.53e+1. What is the difference between the highest and the lowest Imports (BoP, current US$) of 2006?
Offer a very short reply. 5.39e+1. What is the difference between the highest and the lowest Imports (BoP, current US$) of 2007?
Offer a terse response. 6.54e+1. What is the difference between the highest and the lowest Imports (BoP, current US$) in 2008?
Your answer should be compact. 7.21e+1. 